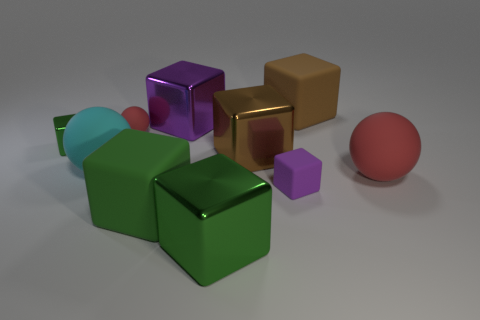Do the cyan thing and the tiny green cube have the same material?
Make the answer very short. No. Do the small green object and the large brown cube that is on the left side of the tiny purple matte block have the same material?
Keep it short and to the point. Yes. There is a tiny matte object that is in front of the red rubber ball behind the big red sphere; what is its shape?
Your response must be concise. Cube. How many large things are either spheres or red rubber spheres?
Give a very brief answer. 2. How many other big cyan objects are the same shape as the cyan matte object?
Ensure brevity in your answer.  0. Do the purple rubber thing and the purple object that is behind the purple matte block have the same shape?
Make the answer very short. Yes. There is a tiny purple rubber object; how many tiny objects are on the right side of it?
Give a very brief answer. 0. Are there any purple cubes that have the same size as the cyan ball?
Keep it short and to the point. Yes. Is the shape of the big brown thing that is in front of the tiny red ball the same as  the big purple metal thing?
Make the answer very short. Yes. What color is the tiny sphere?
Make the answer very short. Red. 